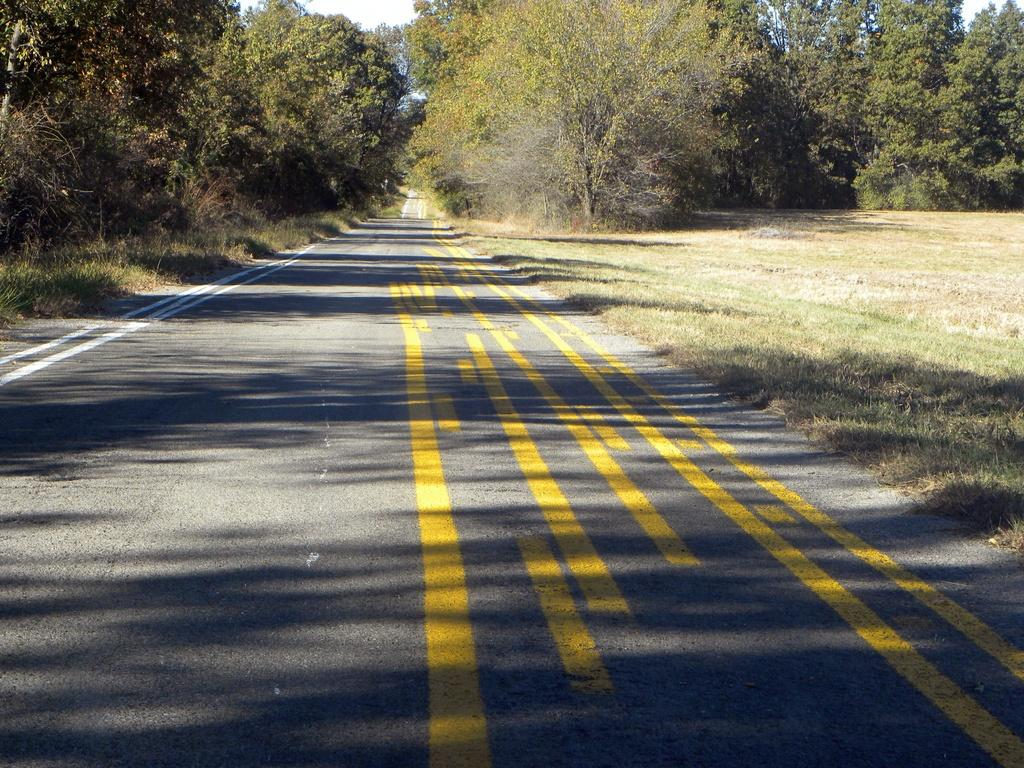What type of surface can be seen in the image? There is a road in the image. What type of vegetation is present in the image? There is grass and trees in the image. What can be seen in the background of the image? The sky is visible in the background of the image. What type of cream is being used to paint the gate in the image? There is no gate or cream present in the image. What direction is the front of the house facing in the image? There is no house or indication of a front direction in the image. 